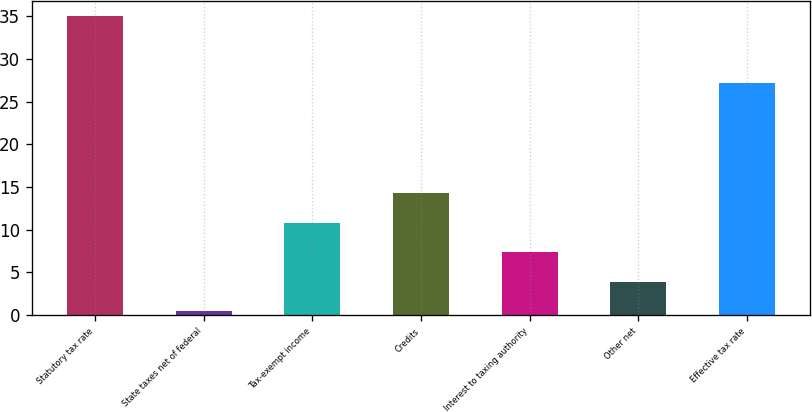Convert chart to OTSL. <chart><loc_0><loc_0><loc_500><loc_500><bar_chart><fcel>Statutory tax rate<fcel>State taxes net of federal<fcel>Tax-exempt income<fcel>Credits<fcel>Interest to taxing authority<fcel>Other net<fcel>Effective tax rate<nl><fcel>35<fcel>0.4<fcel>10.78<fcel>14.24<fcel>7.32<fcel>3.86<fcel>27.2<nl></chart> 